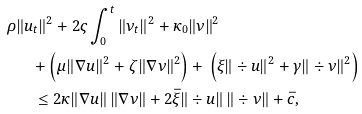<formula> <loc_0><loc_0><loc_500><loc_500>\rho & \| u _ { t } \| ^ { 2 } + 2 \varsigma \int _ { 0 } ^ { t } \| \nu _ { t } \| ^ { 2 } + \kappa _ { 0 } \| \nu \| ^ { 2 } \\ & \quad + \left ( \mu \| \nabla u \| ^ { 2 } + \zeta \| \nabla \nu \| ^ { 2 } \right ) + { } \left ( \xi \| \div u \| ^ { 2 } + \gamma \| \div \nu \| ^ { 2 } \right ) \\ & \quad \, \leq 2 \kappa \| \nabla u \| \, \| \nabla \nu \| + 2 \bar { \xi } \| \div u \| \, \| \div \nu \| + \bar { c } ,</formula> 